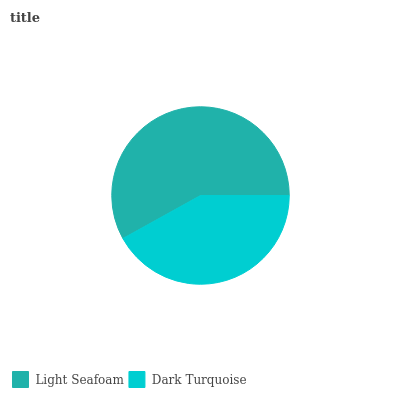Is Dark Turquoise the minimum?
Answer yes or no. Yes. Is Light Seafoam the maximum?
Answer yes or no. Yes. Is Dark Turquoise the maximum?
Answer yes or no. No. Is Light Seafoam greater than Dark Turquoise?
Answer yes or no. Yes. Is Dark Turquoise less than Light Seafoam?
Answer yes or no. Yes. Is Dark Turquoise greater than Light Seafoam?
Answer yes or no. No. Is Light Seafoam less than Dark Turquoise?
Answer yes or no. No. Is Light Seafoam the high median?
Answer yes or no. Yes. Is Dark Turquoise the low median?
Answer yes or no. Yes. Is Dark Turquoise the high median?
Answer yes or no. No. Is Light Seafoam the low median?
Answer yes or no. No. 